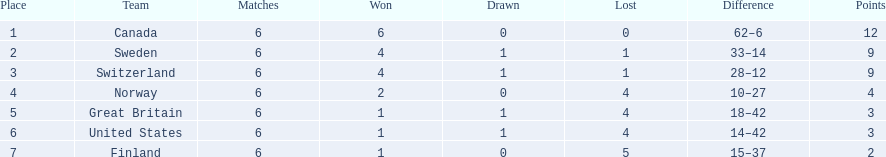What are all the teams? Canada, Sweden, Switzerland, Norway, Great Britain, United States, Finland. What were their points? 12, 9, 9, 4, 3, 3, 2. What about just switzerland and great britain? 9, 3. Now, which of those teams scored higher? Switzerland. 